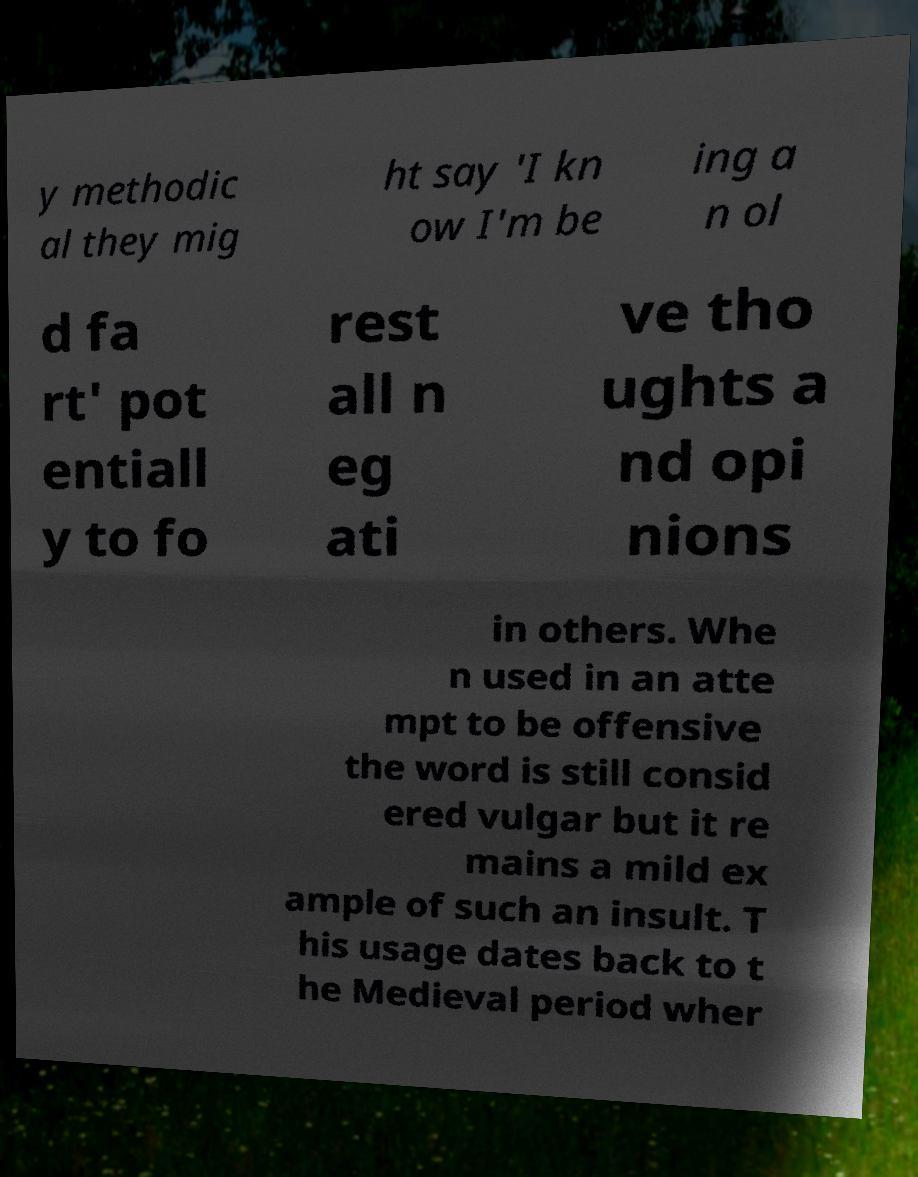Please read and relay the text visible in this image. What does it say? y methodic al they mig ht say 'I kn ow I'm be ing a n ol d fa rt' pot entiall y to fo rest all n eg ati ve tho ughts a nd opi nions in others. Whe n used in an atte mpt to be offensive the word is still consid ered vulgar but it re mains a mild ex ample of such an insult. T his usage dates back to t he Medieval period wher 